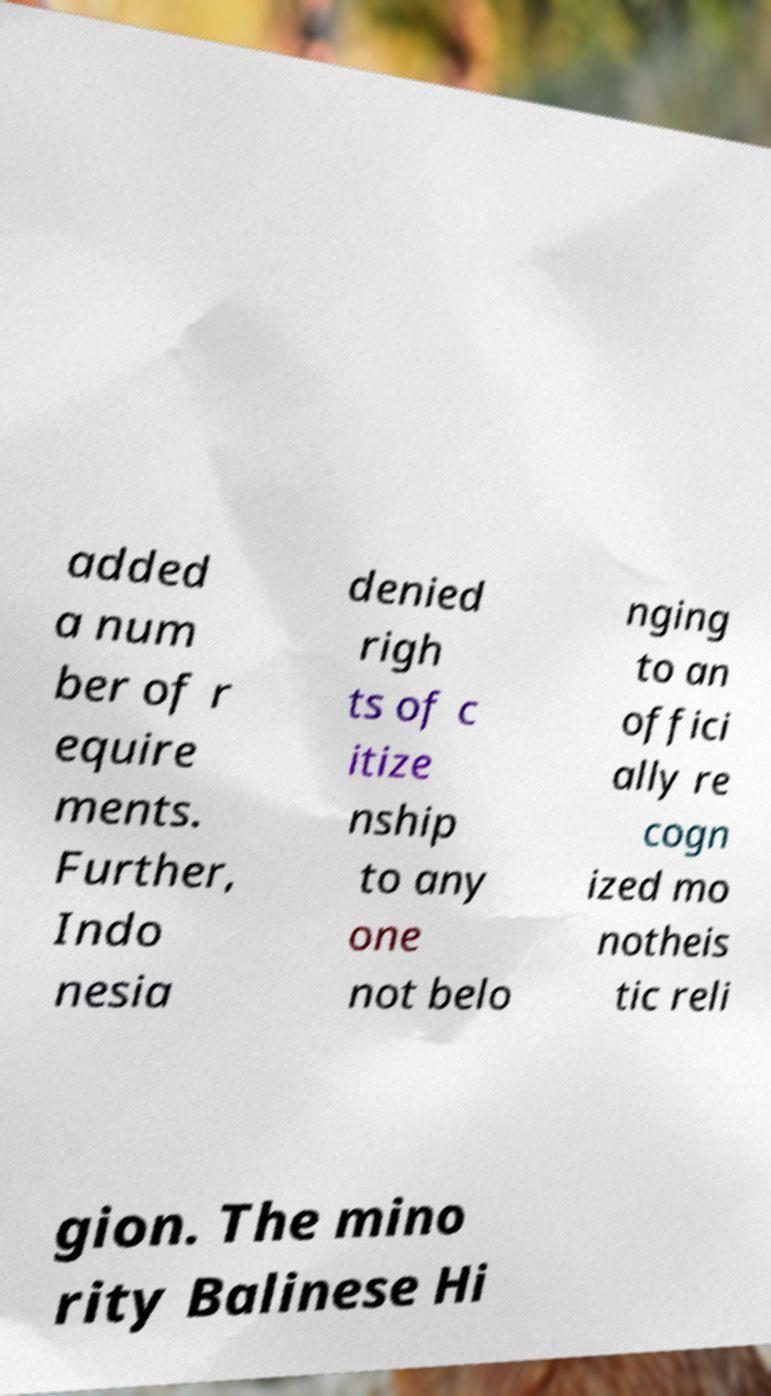For documentation purposes, I need the text within this image transcribed. Could you provide that? added a num ber of r equire ments. Further, Indo nesia denied righ ts of c itize nship to any one not belo nging to an offici ally re cogn ized mo notheis tic reli gion. The mino rity Balinese Hi 